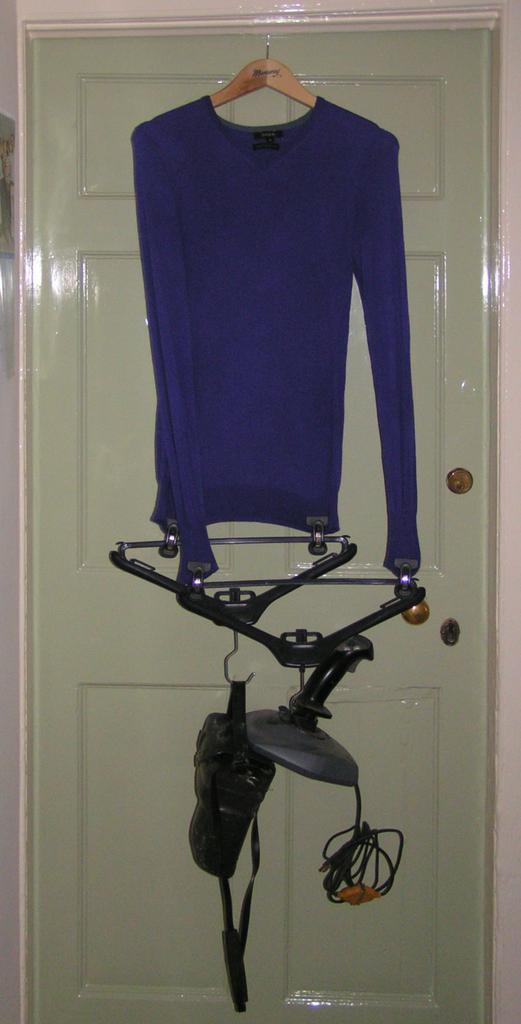In one or two sentences, can you explain what this image depicts? In this picture we can see blue t-shirts hanging on the hanger. On the door we can see the hangers and camera. Beside that there is a wall. 